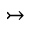<formula> <loc_0><loc_0><loc_500><loc_500>\rightarrow t a i l</formula> 